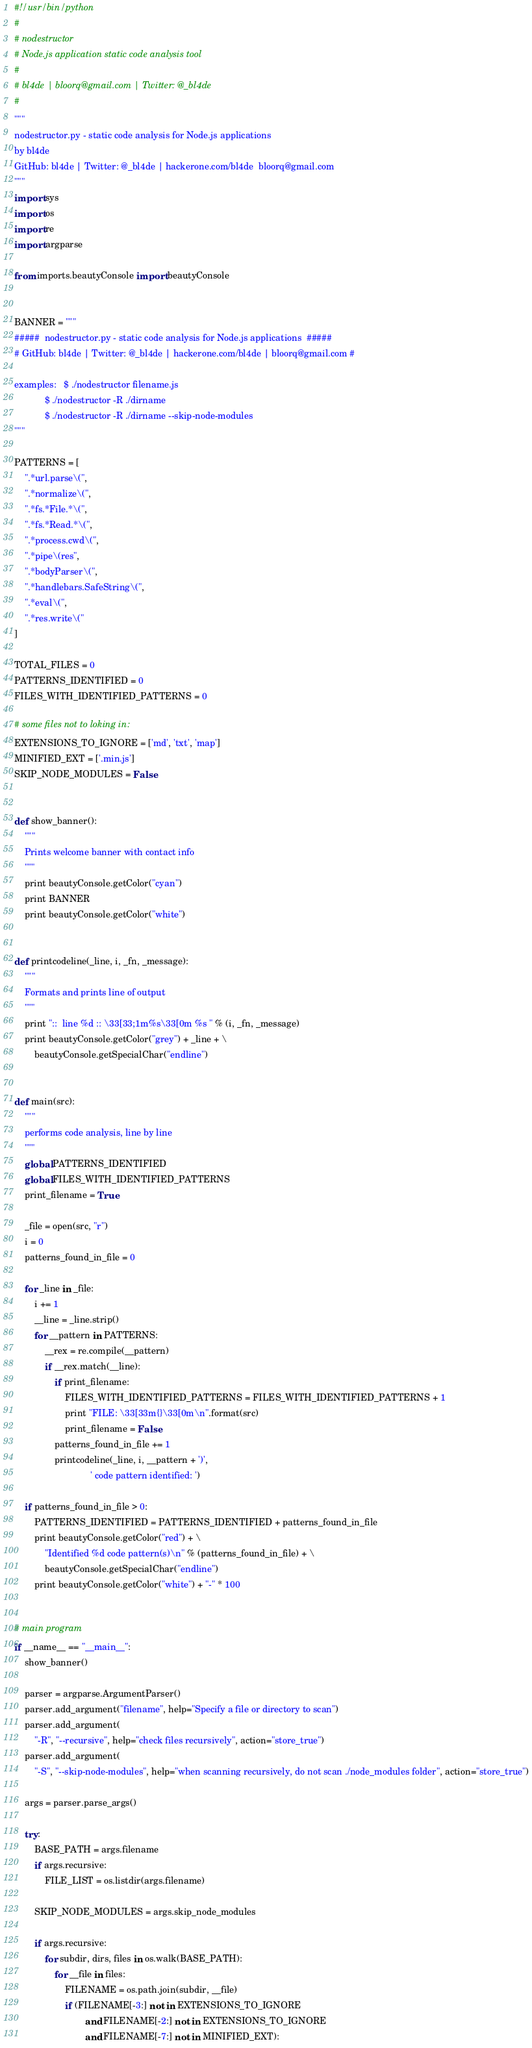<code> <loc_0><loc_0><loc_500><loc_500><_Python_>#!/usr/bin/python
#
# nodestructor
# Node.js application static code analysis tool
#
# bl4de | bloorq@gmail.com | Twitter: @_bl4de
#
"""
nodestructor.py - static code analysis for Node.js applications
by bl4de
GitHub: bl4de | Twitter: @_bl4de | hackerone.com/bl4de  bloorq@gmail.com
"""
import sys
import os
import re
import argparse

from imports.beautyConsole import beautyConsole


BANNER = """
#####  nodestructor.py - static code analysis for Node.js applications  #####
# GitHub: bl4de | Twitter: @_bl4de | hackerone.com/bl4de | bloorq@gmail.com #

examples:   $ ./nodestructor filename.js
            $ ./nodestructor -R ./dirname
            $ ./nodestructor -R ./dirname --skip-node-modules
"""

PATTERNS = [
    ".*url.parse\(",
    ".*normalize\(",
    ".*fs.*File.*\(",
    ".*fs.*Read.*\(",
    ".*process.cwd\(",
    ".*pipe\(res",
    ".*bodyParser\(",
    ".*handlebars.SafeString\(",
    ".*eval\(",
    ".*res.write\("
]

TOTAL_FILES = 0
PATTERNS_IDENTIFIED = 0
FILES_WITH_IDENTIFIED_PATTERNS = 0

# some files not to loking in:
EXTENSIONS_TO_IGNORE = ['md', 'txt', 'map']
MINIFIED_EXT = ['.min.js']
SKIP_NODE_MODULES = False


def show_banner():
    """
    Prints welcome banner with contact info
    """
    print beautyConsole.getColor("cyan")
    print BANNER
    print beautyConsole.getColor("white")


def printcodeline(_line, i, _fn, _message):
    """
    Formats and prints line of output
    """
    print "::  line %d :: \33[33;1m%s\33[0m %s " % (i, _fn, _message)
    print beautyConsole.getColor("grey") + _line + \
        beautyConsole.getSpecialChar("endline")


def main(src):
    """
    performs code analysis, line by line
    """
    global PATTERNS_IDENTIFIED
    global FILES_WITH_IDENTIFIED_PATTERNS
    print_filename = True

    _file = open(src, "r")
    i = 0
    patterns_found_in_file = 0

    for _line in _file:
        i += 1
        __line = _line.strip()
        for __pattern in PATTERNS:
            __rex = re.compile(__pattern)
            if __rex.match(__line):
                if print_filename:
                    FILES_WITH_IDENTIFIED_PATTERNS = FILES_WITH_IDENTIFIED_PATTERNS + 1
                    print "FILE: \33[33m{}\33[0m\n".format(src)
                    print_filename = False
                patterns_found_in_file += 1
                printcodeline(_line, i, __pattern + ')',
                              ' code pattern identified: ')

    if patterns_found_in_file > 0:
        PATTERNS_IDENTIFIED = PATTERNS_IDENTIFIED + patterns_found_in_file
        print beautyConsole.getColor("red") + \
            "Identified %d code pattern(s)\n" % (patterns_found_in_file) + \
            beautyConsole.getSpecialChar("endline")
        print beautyConsole.getColor("white") + "-" * 100


# main program
if __name__ == "__main__":
    show_banner()

    parser = argparse.ArgumentParser()
    parser.add_argument("filename", help="Specify a file or directory to scan")
    parser.add_argument(
        "-R", "--recursive", help="check files recursively", action="store_true")
    parser.add_argument(
        "-S", "--skip-node-modules", help="when scanning recursively, do not scan ./node_modules folder", action="store_true")

    args = parser.parse_args()

    try:
        BASE_PATH = args.filename
        if args.recursive:
            FILE_LIST = os.listdir(args.filename)

        SKIP_NODE_MODULES = args.skip_node_modules

        if args.recursive:
            for subdir, dirs, files in os.walk(BASE_PATH):
                for __file in files:
                    FILENAME = os.path.join(subdir, __file)
                    if (FILENAME[-3:] not in EXTENSIONS_TO_IGNORE
                            and FILENAME[-2:] not in EXTENSIONS_TO_IGNORE
                            and FILENAME[-7:] not in MINIFIED_EXT):</code> 